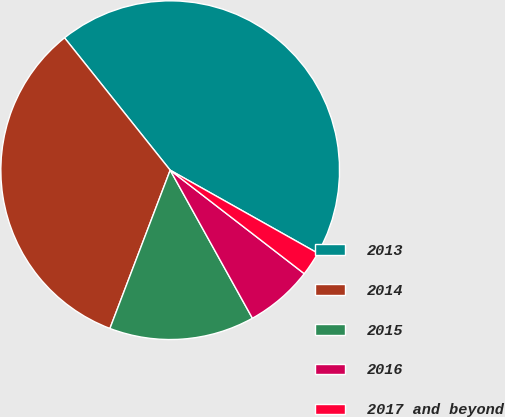Convert chart. <chart><loc_0><loc_0><loc_500><loc_500><pie_chart><fcel>2013<fcel>2014<fcel>2015<fcel>2016<fcel>2017 and beyond<nl><fcel>43.88%<fcel>33.49%<fcel>13.86%<fcel>6.47%<fcel>2.31%<nl></chart> 